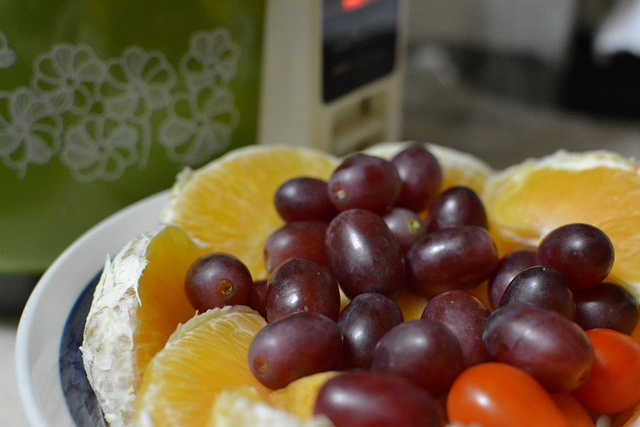Describe the objects in this image and their specific colors. I can see bowl in darkgreen, darkgray, lightgray, gray, and black tones, orange in darkgreen, lightgray, olive, and darkgray tones, orange in darkgreen, orange, tan, and olive tones, orange in darkgreen, tan, orange, and darkgray tones, and orange in darkgreen, olive, and tan tones in this image. 